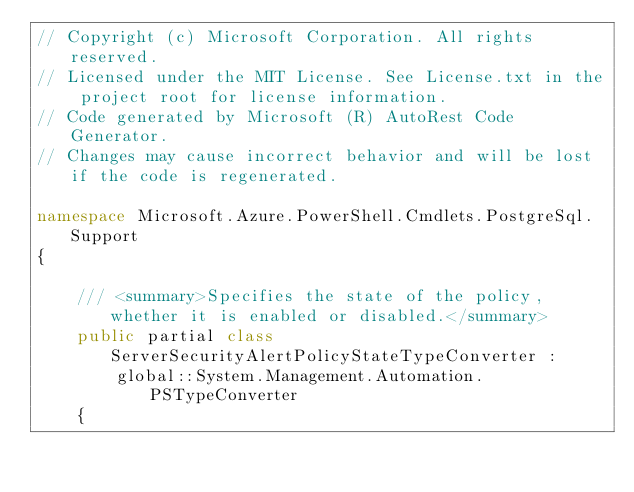<code> <loc_0><loc_0><loc_500><loc_500><_C#_>// Copyright (c) Microsoft Corporation. All rights reserved.
// Licensed under the MIT License. See License.txt in the project root for license information.
// Code generated by Microsoft (R) AutoRest Code Generator.
// Changes may cause incorrect behavior and will be lost if the code is regenerated.

namespace Microsoft.Azure.PowerShell.Cmdlets.PostgreSql.Support
{

    /// <summary>Specifies the state of the policy, whether it is enabled or disabled.</summary>
    public partial class ServerSecurityAlertPolicyStateTypeConverter :
        global::System.Management.Automation.PSTypeConverter
    {
</code> 